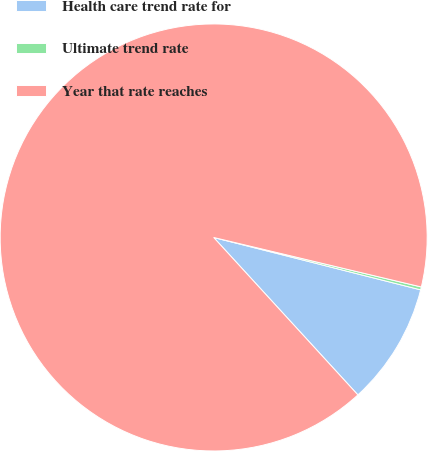<chart> <loc_0><loc_0><loc_500><loc_500><pie_chart><fcel>Health care trend rate for<fcel>Ultimate trend rate<fcel>Year that rate reaches<nl><fcel>9.25%<fcel>0.22%<fcel>90.52%<nl></chart> 